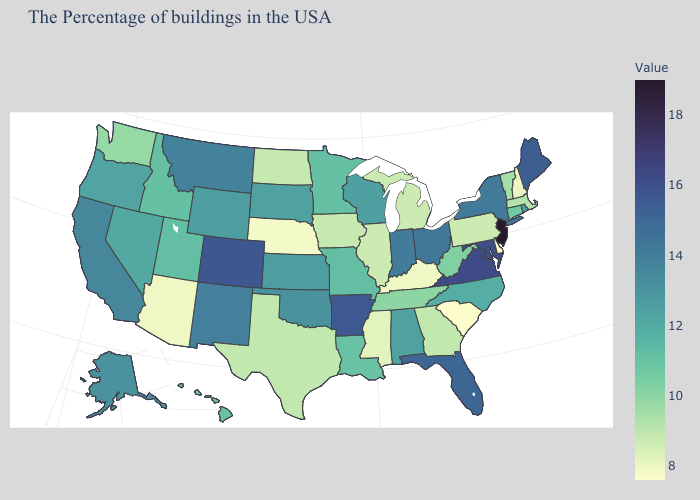Among the states that border Arkansas , does Mississippi have the lowest value?
Be succinct. Yes. Which states hav the highest value in the West?
Be succinct. Colorado. 